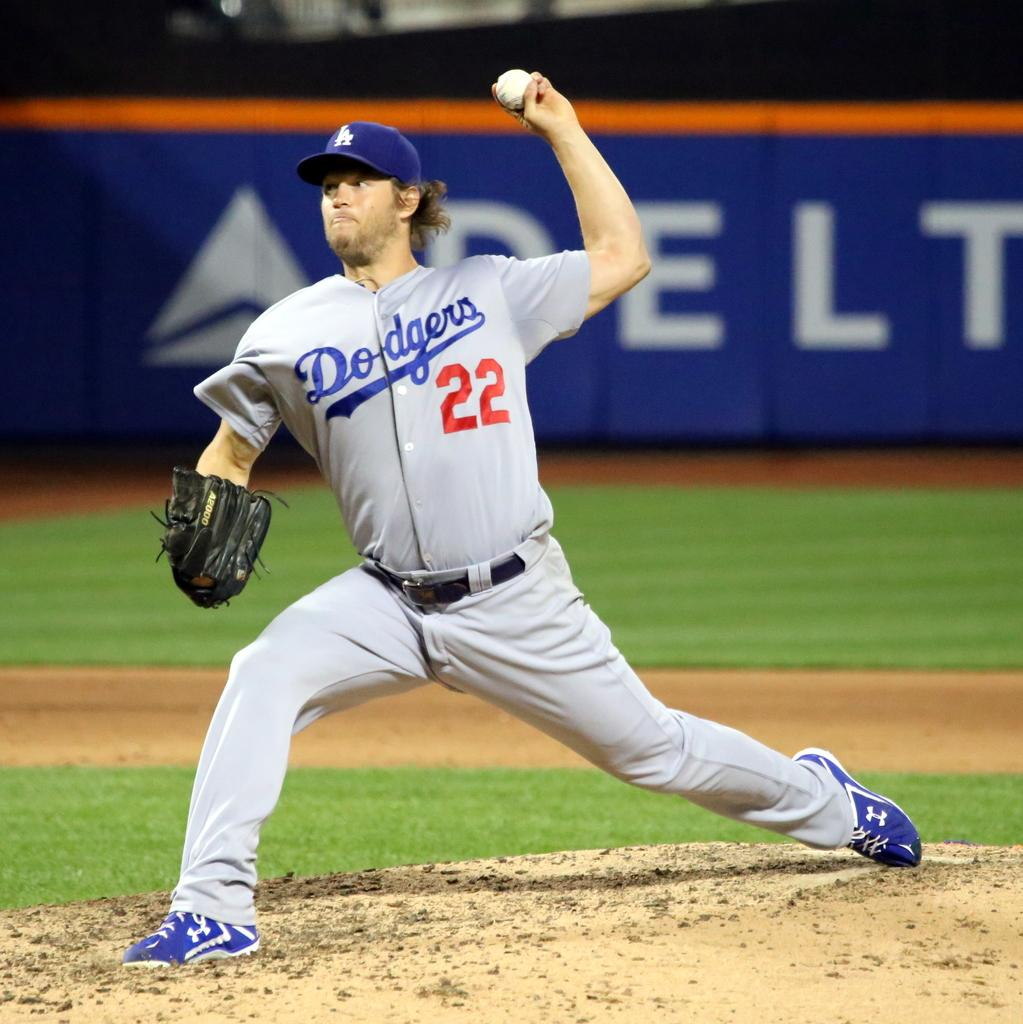<image>
Provide a brief description of the given image. dodgers pitcher #22 throwing the ball with delta sign in background 